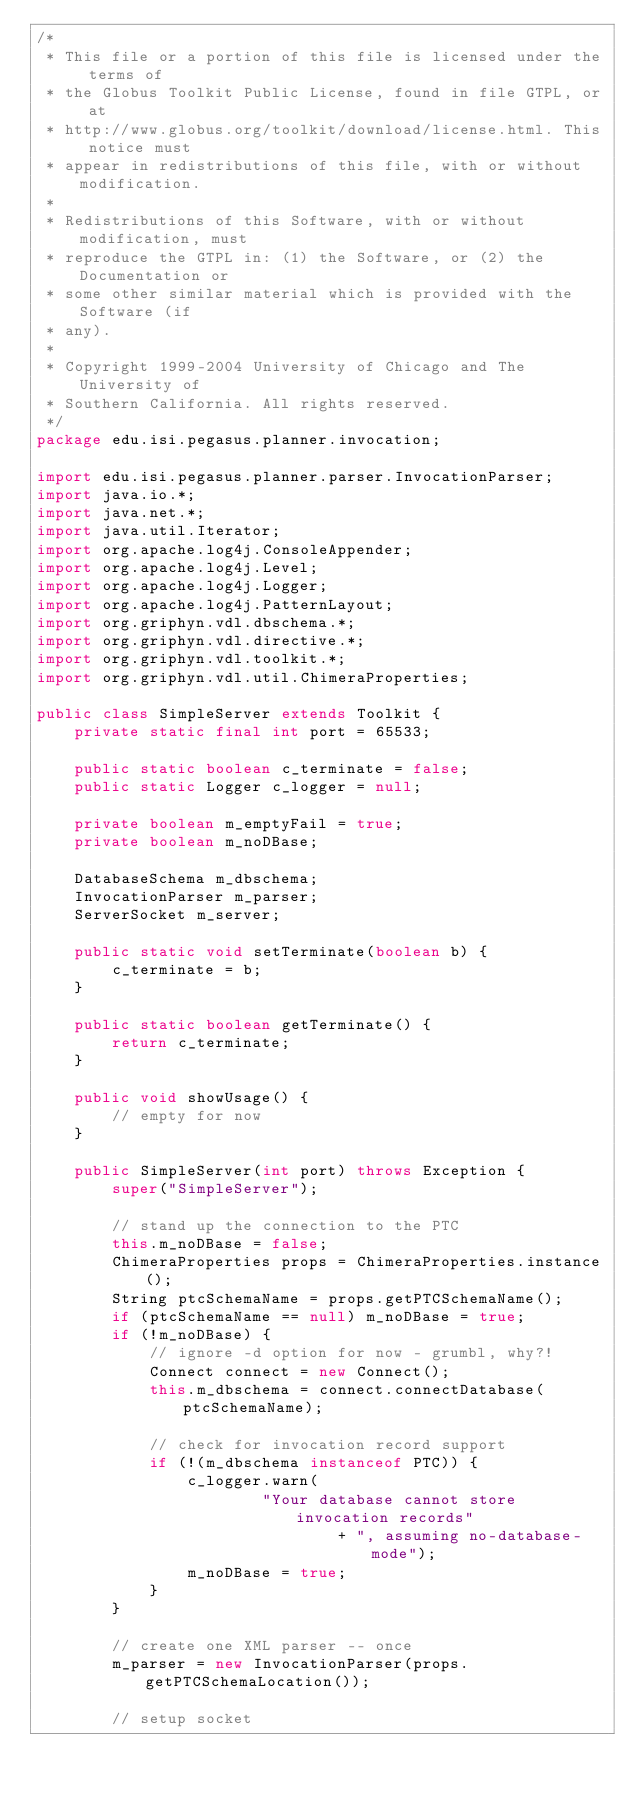Convert code to text. <code><loc_0><loc_0><loc_500><loc_500><_Java_>/*
 * This file or a portion of this file is licensed under the terms of
 * the Globus Toolkit Public License, found in file GTPL, or at
 * http://www.globus.org/toolkit/download/license.html. This notice must
 * appear in redistributions of this file, with or without modification.
 *
 * Redistributions of this Software, with or without modification, must
 * reproduce the GTPL in: (1) the Software, or (2) the Documentation or
 * some other similar material which is provided with the Software (if
 * any).
 *
 * Copyright 1999-2004 University of Chicago and The University of
 * Southern California. All rights reserved.
 */
package edu.isi.pegasus.planner.invocation;

import edu.isi.pegasus.planner.parser.InvocationParser;
import java.io.*;
import java.net.*;
import java.util.Iterator;
import org.apache.log4j.ConsoleAppender;
import org.apache.log4j.Level;
import org.apache.log4j.Logger;
import org.apache.log4j.PatternLayout;
import org.griphyn.vdl.dbschema.*;
import org.griphyn.vdl.directive.*;
import org.griphyn.vdl.toolkit.*;
import org.griphyn.vdl.util.ChimeraProperties;

public class SimpleServer extends Toolkit {
    private static final int port = 65533;

    public static boolean c_terminate = false;
    public static Logger c_logger = null;

    private boolean m_emptyFail = true;
    private boolean m_noDBase;

    DatabaseSchema m_dbschema;
    InvocationParser m_parser;
    ServerSocket m_server;

    public static void setTerminate(boolean b) {
        c_terminate = b;
    }

    public static boolean getTerminate() {
        return c_terminate;
    }

    public void showUsage() {
        // empty for now
    }

    public SimpleServer(int port) throws Exception {
        super("SimpleServer");

        // stand up the connection to the PTC
        this.m_noDBase = false;
        ChimeraProperties props = ChimeraProperties.instance();
        String ptcSchemaName = props.getPTCSchemaName();
        if (ptcSchemaName == null) m_noDBase = true;
        if (!m_noDBase) {
            // ignore -d option for now - grumbl, why?!
            Connect connect = new Connect();
            this.m_dbschema = connect.connectDatabase(ptcSchemaName);

            // check for invocation record support
            if (!(m_dbschema instanceof PTC)) {
                c_logger.warn(
                        "Your database cannot store invocation records"
                                + ", assuming no-database-mode");
                m_noDBase = true;
            }
        }

        // create one XML parser -- once
        m_parser = new InvocationParser(props.getPTCSchemaLocation());

        // setup socket</code> 